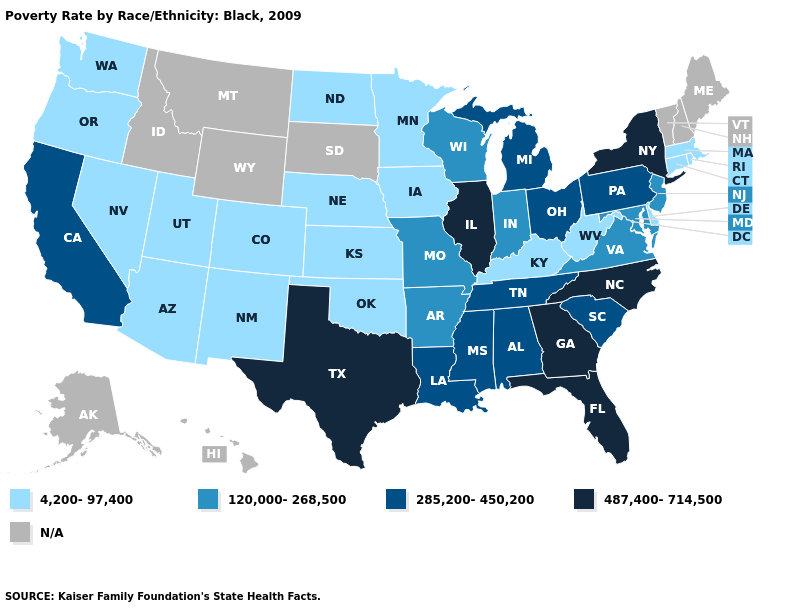Among the states that border Connecticut , does New York have the lowest value?
Write a very short answer. No. What is the value of South Carolina?
Answer briefly. 285,200-450,200. Name the states that have a value in the range N/A?
Quick response, please. Alaska, Hawaii, Idaho, Maine, Montana, New Hampshire, South Dakota, Vermont, Wyoming. Does the map have missing data?
Quick response, please. Yes. Does North Carolina have the highest value in the South?
Answer briefly. Yes. How many symbols are there in the legend?
Short answer required. 5. What is the lowest value in the USA?
Keep it brief. 4,200-97,400. What is the lowest value in the USA?
Be succinct. 4,200-97,400. How many symbols are there in the legend?
Short answer required. 5. What is the value of Washington?
Be succinct. 4,200-97,400. Name the states that have a value in the range 120,000-268,500?
Answer briefly. Arkansas, Indiana, Maryland, Missouri, New Jersey, Virginia, Wisconsin. Does North Dakota have the lowest value in the USA?
Concise answer only. Yes. What is the value of New York?
Give a very brief answer. 487,400-714,500. Name the states that have a value in the range N/A?
Be succinct. Alaska, Hawaii, Idaho, Maine, Montana, New Hampshire, South Dakota, Vermont, Wyoming. 